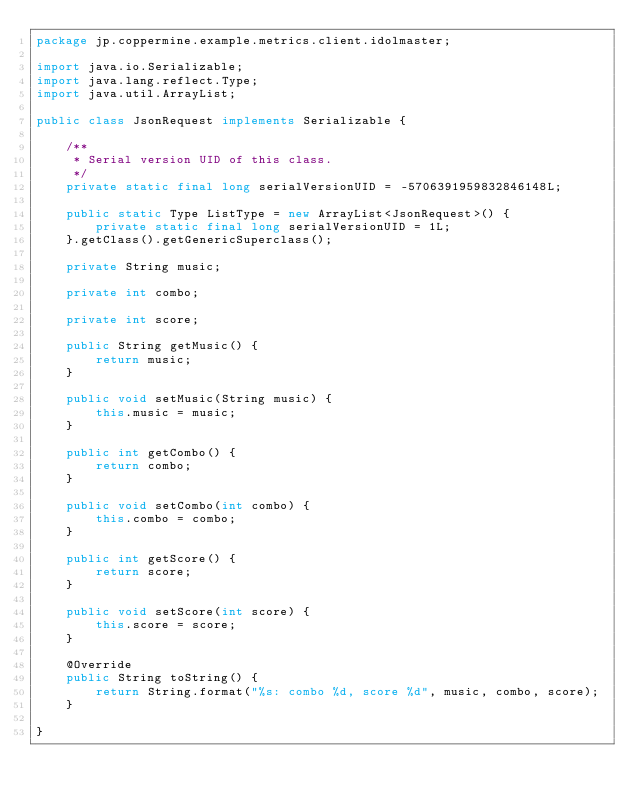Convert code to text. <code><loc_0><loc_0><loc_500><loc_500><_Java_>package jp.coppermine.example.metrics.client.idolmaster;

import java.io.Serializable;
import java.lang.reflect.Type;
import java.util.ArrayList;

public class JsonRequest implements Serializable {
    
    /**
     * Serial version UID of this class.
     */
    private static final long serialVersionUID = -5706391959832846148L;
    
    public static Type ListType = new ArrayList<JsonRequest>() {
        private static final long serialVersionUID = 1L;
    }.getClass().getGenericSuperclass();
    
    private String music;
    
    private int combo;
    
    private int score;

    public String getMusic() {
        return music;
    }

    public void setMusic(String music) {
        this.music = music;
    }

    public int getCombo() {
        return combo;
    }

    public void setCombo(int combo) {
        this.combo = combo;
    }

    public int getScore() {
        return score;
    }

    public void setScore(int score) {
        this.score = score;
    }

    @Override
    public String toString() {
        return String.format("%s: combo %d, score %d", music, combo, score);
    }
    
}
</code> 